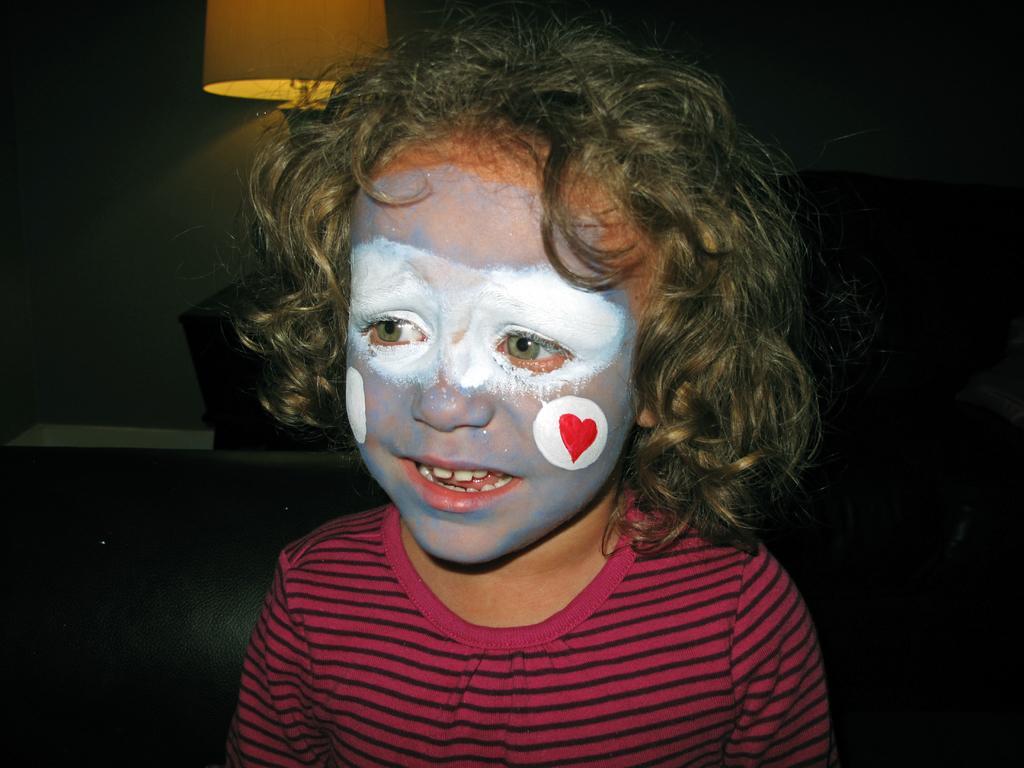In one or two sentences, can you explain what this image depicts? In this image a baby is standing and she painted her face with few colors. There is a lamp at the top left most of the image. 